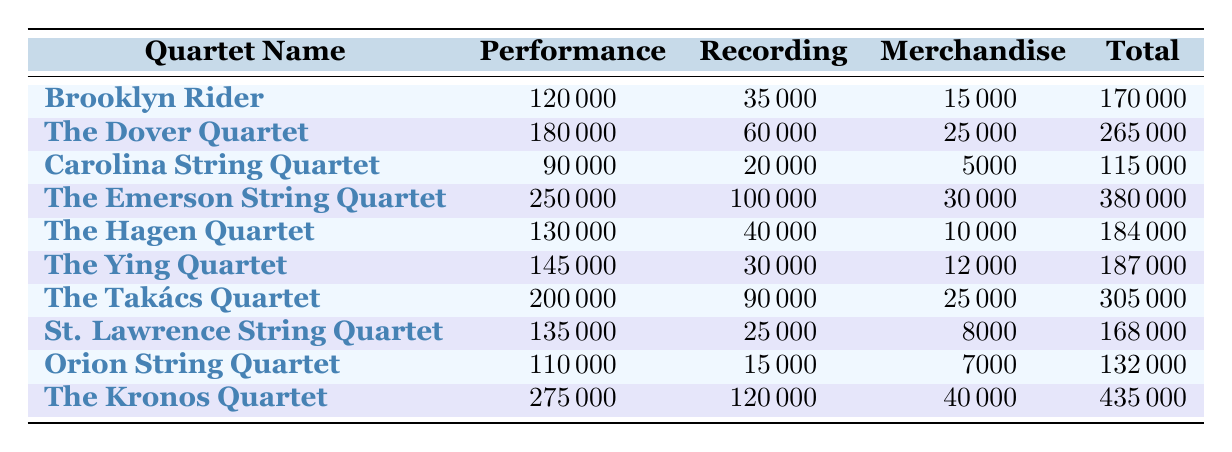What is the total revenue for The Emerson String Quartet? Looking at the table, the total revenue listed for The Emerson String Quartet is 380000.
Answer: 380000 Which quartet generated the highest revenue from performances? By comparing the performance revenue for each quartet, The Kronos Quartet has the highest at 275000.
Answer: The Kronos Quartet What is the combined merchandise revenue for the top three quartets by total revenue? The top three quartets by total revenue are The Kronos Quartet (40000), The Emerson String Quartet (30000), and The Dover Quartet (25000). Adding these values gives: 40000 + 30000 + 25000 = 95000.
Answer: 95000 Is the total revenue for The Ying Quartet greater than that of The Hagen Quartet? The total revenue for The Ying Quartet is 187000, while for The Hagen Quartet it is 184000. Since 187000 is greater than 184000, the answer is yes.
Answer: Yes What is the average performance revenue from all quartets listed? To find the average performance revenue, sum all performance revenues: 120000 + 180000 + 90000 + 250000 + 130000 + 145000 + 200000 + 135000 + 110000 + 275000 = 1345000. There are 10 quartets, so the average is 1345000 / 10 = 134500.
Answer: 134500 How much revenue did The Takács Quartet make from merchandise? The Takács Quartet's merchandise revenue is explicitly listed as 25000 in the table.
Answer: 25000 Which quartet has the smallest total revenue and what is that revenue? By scanning the total revenue column, the Carolina String Quartet has the smallest total revenue at 115000.
Answer: 115000 If The Kronos Quartet and The Takács Quartet were combined, what would their total revenue be? The total revenue for The Kronos Quartet is 435000 and for The Takács Quartet it is 305000. Adding these gives 435000 + 305000 = 740000.
Answer: 740000 How much more did The Dover Quartet earn from recordings than The Ying Quartet? The Dover Quartet earned 60000 from recordings while The Ying Quartet earned 30000. The difference is 60000 - 30000 = 30000.
Answer: 30000 Is the merchandise revenue for The Hagen Quartet more than 10000? The merchandise revenue for The Hagen Quartet is 10000, which is not more than 10000. Therefore, the answer is no.
Answer: No 